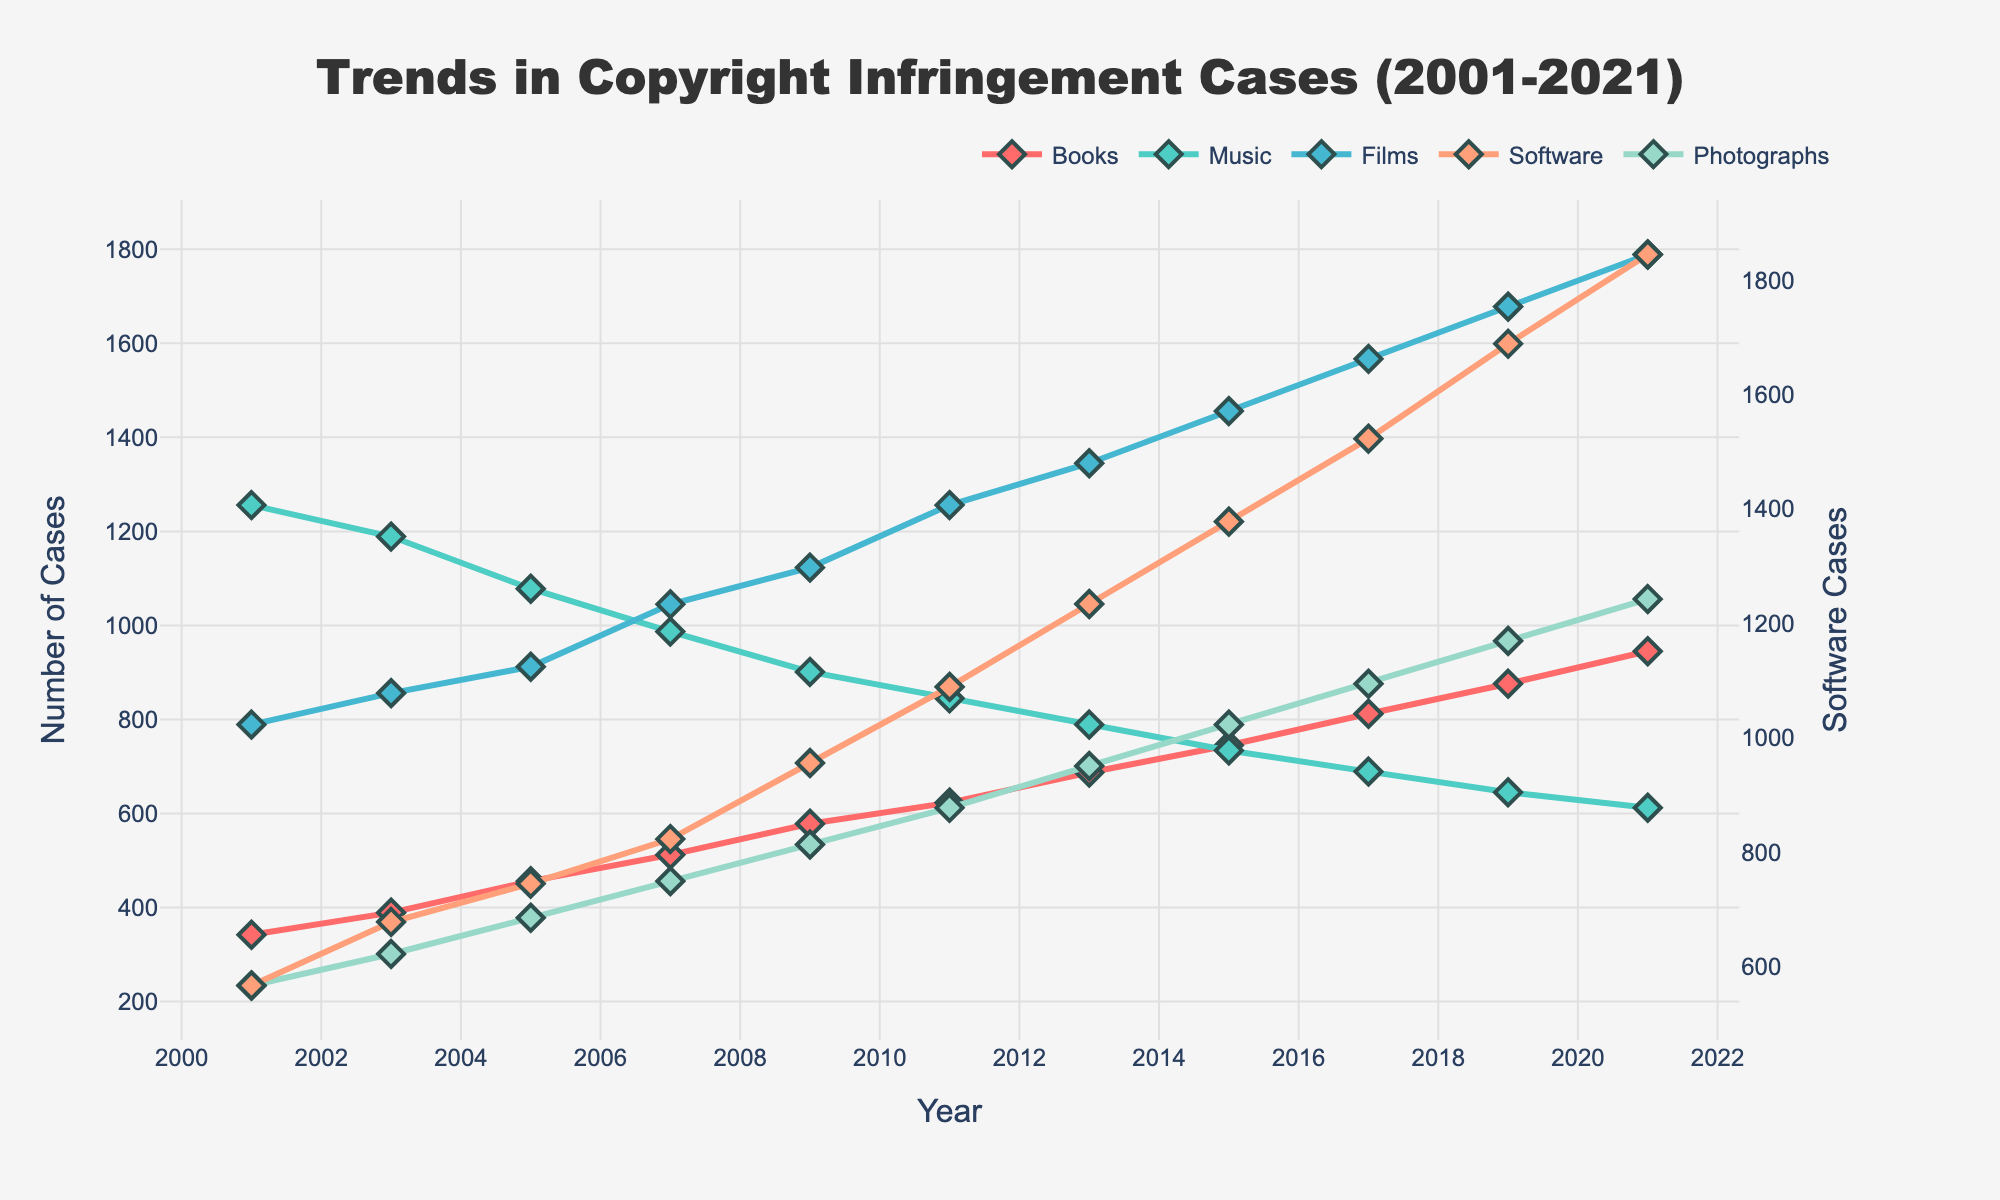What type of creative work had the highest number of copyright infringement cases in 2021? The chart indicates that the line representing "Films" is at the highest point compared to other creative works in 2021, showing the maximum value.
Answer: Films How did the number of copyright infringement cases for books change from 2001 to 2011? The number of copyright infringement cases for books increased from 342 in 2001 to 623 in 2011, showing an upward trend.
Answer: Increased Which type of creative work had the most significant increase in the number of cases between 2001 and 2021? By comparing the lines, "Software" had the most pronounced rise, starting at 567 cases in 2001 and increasing to 1845 cases in 2021.
Answer: Software In which year did the number of music-related copyright infringement cases peak? The chart shows that the number of music-related cases was highest in 2001, with subsequent values consistently lower in subsequent years.
Answer: 2001 How many more cases of film-related copyright infringement were there in 2021 compared to 2001? In 2021, there were 1789 cases, and in 2001, there were 789 cases. Subtracting these gives 1789 - 789 = 1000.
Answer: 1000 Which two types of creative works had the closest number of copyright infringement cases in 2005? Observing the lines, "Books" and "Software" had relatively close values with 456 and 745 cases, respectively, while other categories had more significant differences among them.
Answer: Books and Software What is the average number of copyright infringement cases for photographs from 2001 to 2021? Summing the cases for photographs from each year: 234, 301, 378, 456, 534, 612, 701, 789, 876, 967, and 1056 equals 6894. Dividing by 11 (the number of years) results in 6894 / 11 = 626.73.
Answer: 626.73 Which type of creative work showed the most stable trend over the 20 years? The line for "Music" generally shows a declining trend but remains more stable and less varied than other categories over the period.
Answer: Music How did the trends for film and software-related copyright infringement cases compare over the last two decades? Both "Films" and "Software" show significant upward trends. However, the rise in software cases is more dramatic, with "Software" starting at a lower point and ending at a similar height as "Films."
Answer: Both upward, with Software more dramatic In what year did the number of copyright infringement cases for books surpass 800? According to the chart, the number of cases for books first exceeded 800 in 2017.
Answer: 2017 